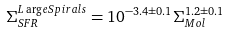Convert formula to latex. <formula><loc_0><loc_0><loc_500><loc_500>\Sigma _ { S F R } ^ { L \arg e S p i r a l s } = 1 0 ^ { - 3 . 4 \pm 0 . 1 } \Sigma _ { M o l } ^ { 1 . 2 \pm 0 . 1 }</formula> 